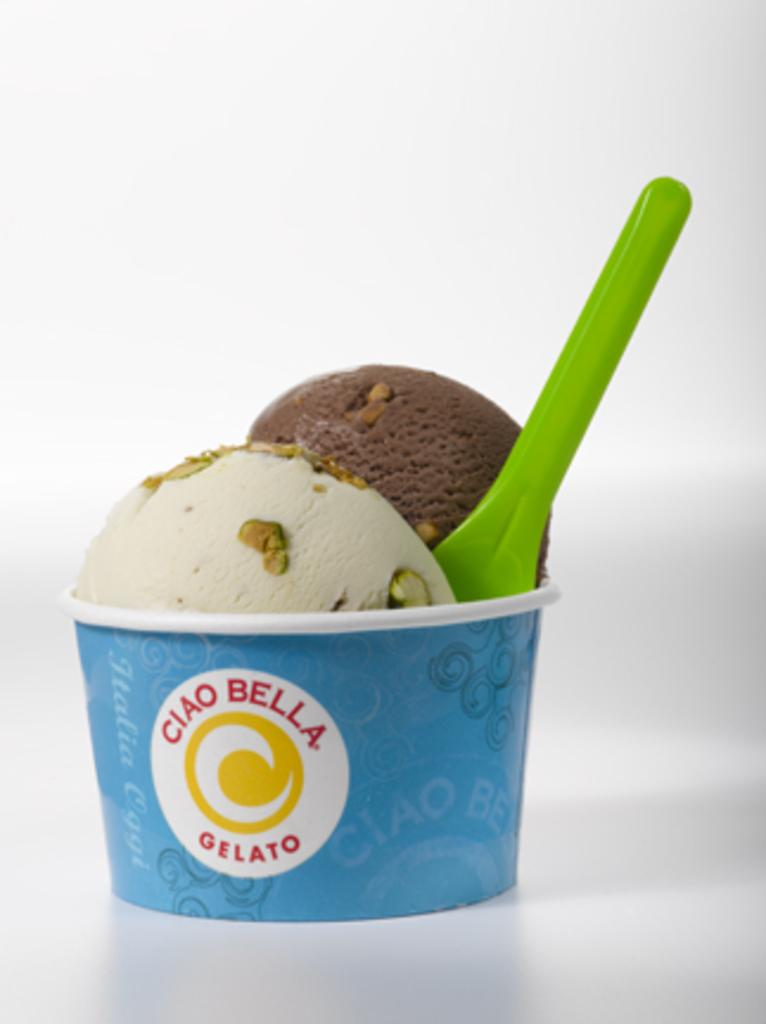What type of dessert is featured in the image? There is an ice cream cup in the image. What flavors are present in the ice cream? The ice cream has vanilla and chocolate flavors. What color is the spoon in the image? There is a green spoon in the image. What part of the human body is responsible for the creation of the ice cream in the image? The ice cream in the image was not created by a human body part; it was made by a manufacturer or chef. 